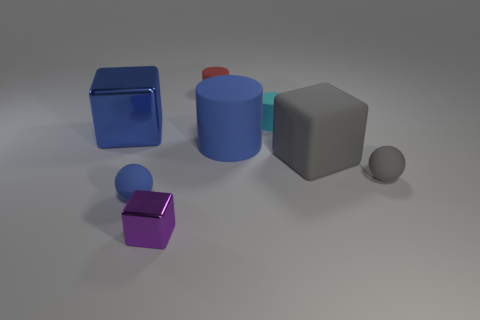Subtract all large blue shiny blocks. How many blocks are left? 2 Add 1 red rubber cylinders. How many objects exist? 9 Add 8 large metallic things. How many large metallic things exist? 9 Subtract 1 blue balls. How many objects are left? 7 Subtract all blocks. How many objects are left? 5 Subtract all green things. Subtract all rubber cubes. How many objects are left? 7 Add 4 blue rubber balls. How many blue rubber balls are left? 5 